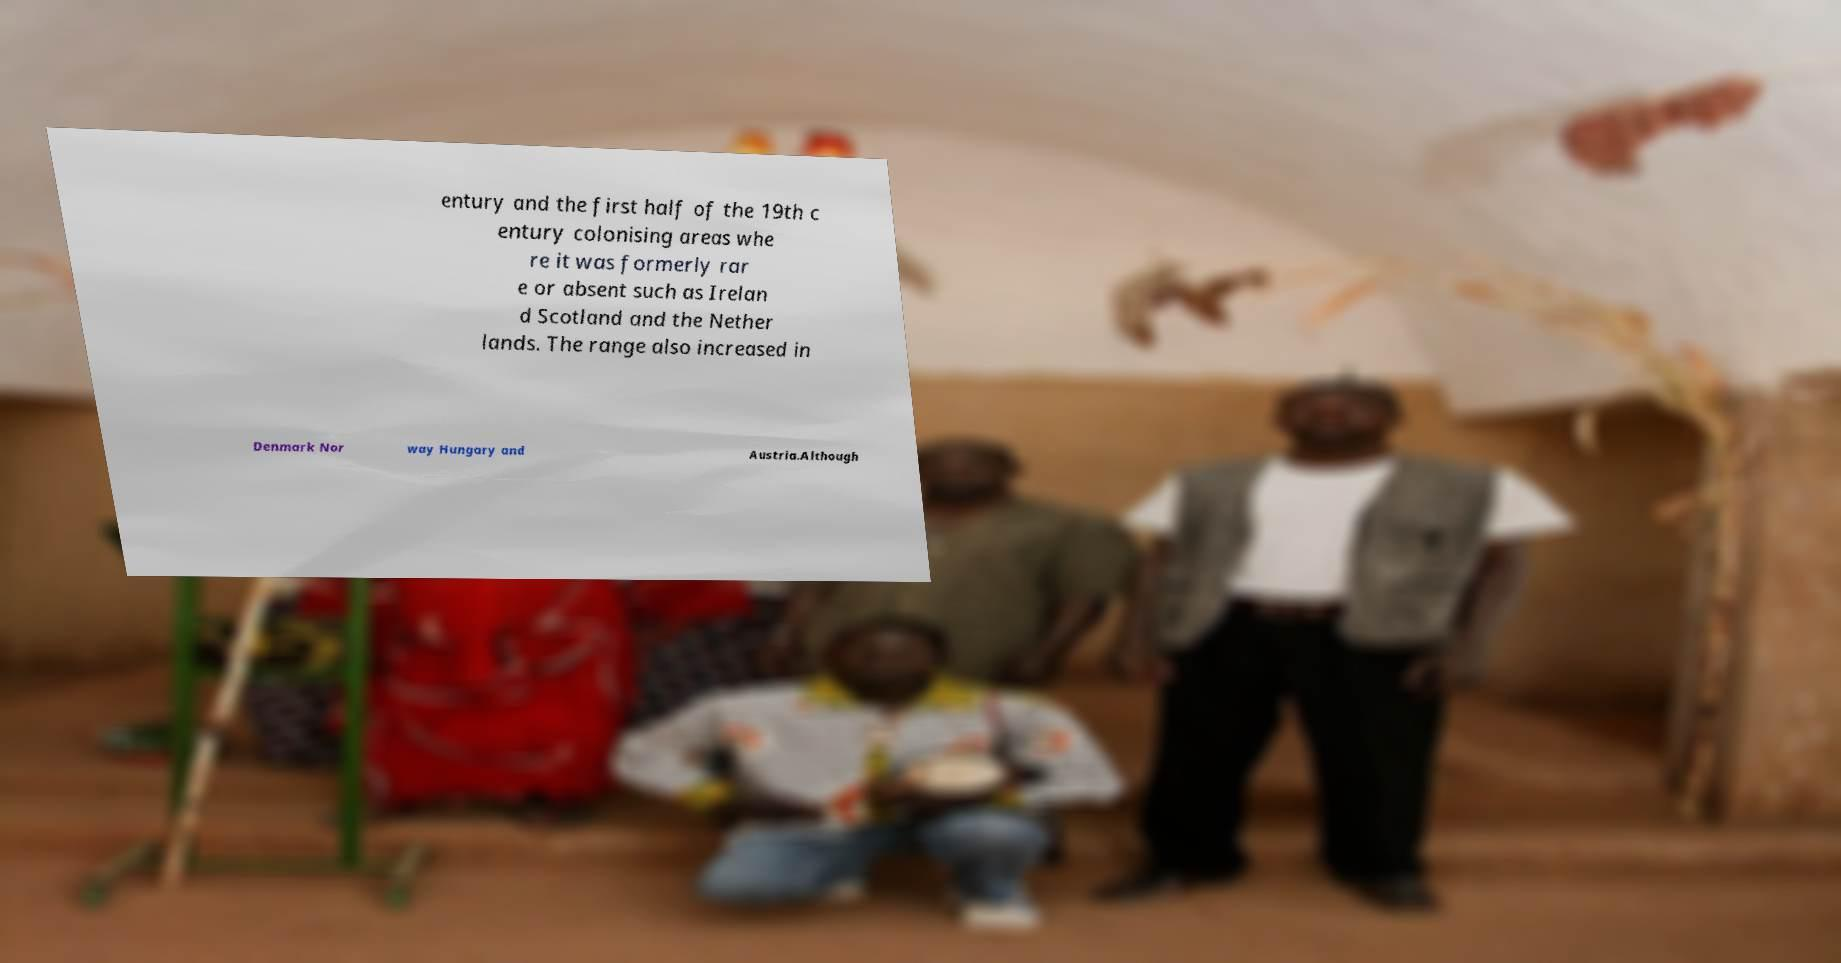What messages or text are displayed in this image? I need them in a readable, typed format. entury and the first half of the 19th c entury colonising areas whe re it was formerly rar e or absent such as Irelan d Scotland and the Nether lands. The range also increased in Denmark Nor way Hungary and Austria.Although 